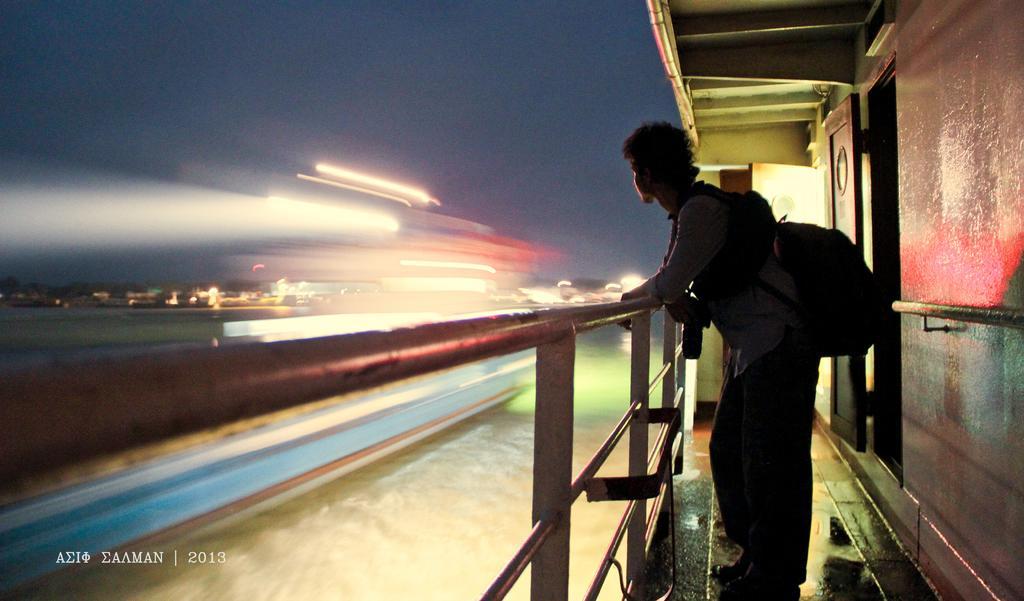In one or two sentences, can you explain what this image depicts? In this image there is the sky towards the top of the image, there are light rays, there is a man standing, he is wearing a bag, there is the wall towards the right of the image, there is a door, there is roof towards the top of the image, there is a metal object towards the left of the image, there is text towards the bottom of the image, there is a number towards the bottom of the image. 